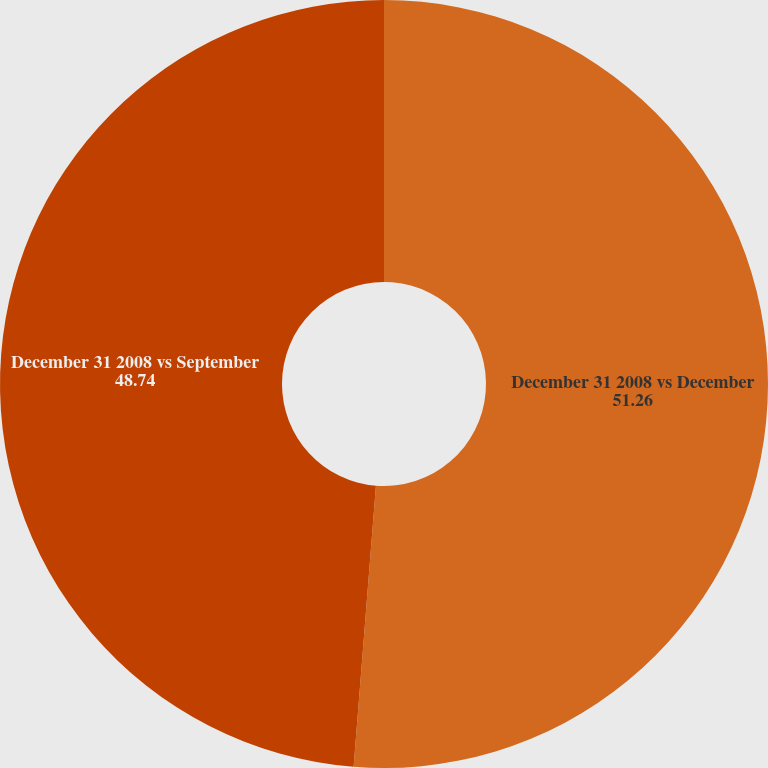<chart> <loc_0><loc_0><loc_500><loc_500><pie_chart><fcel>December 31 2008 vs December<fcel>December 31 2008 vs September<nl><fcel>51.26%<fcel>48.74%<nl></chart> 